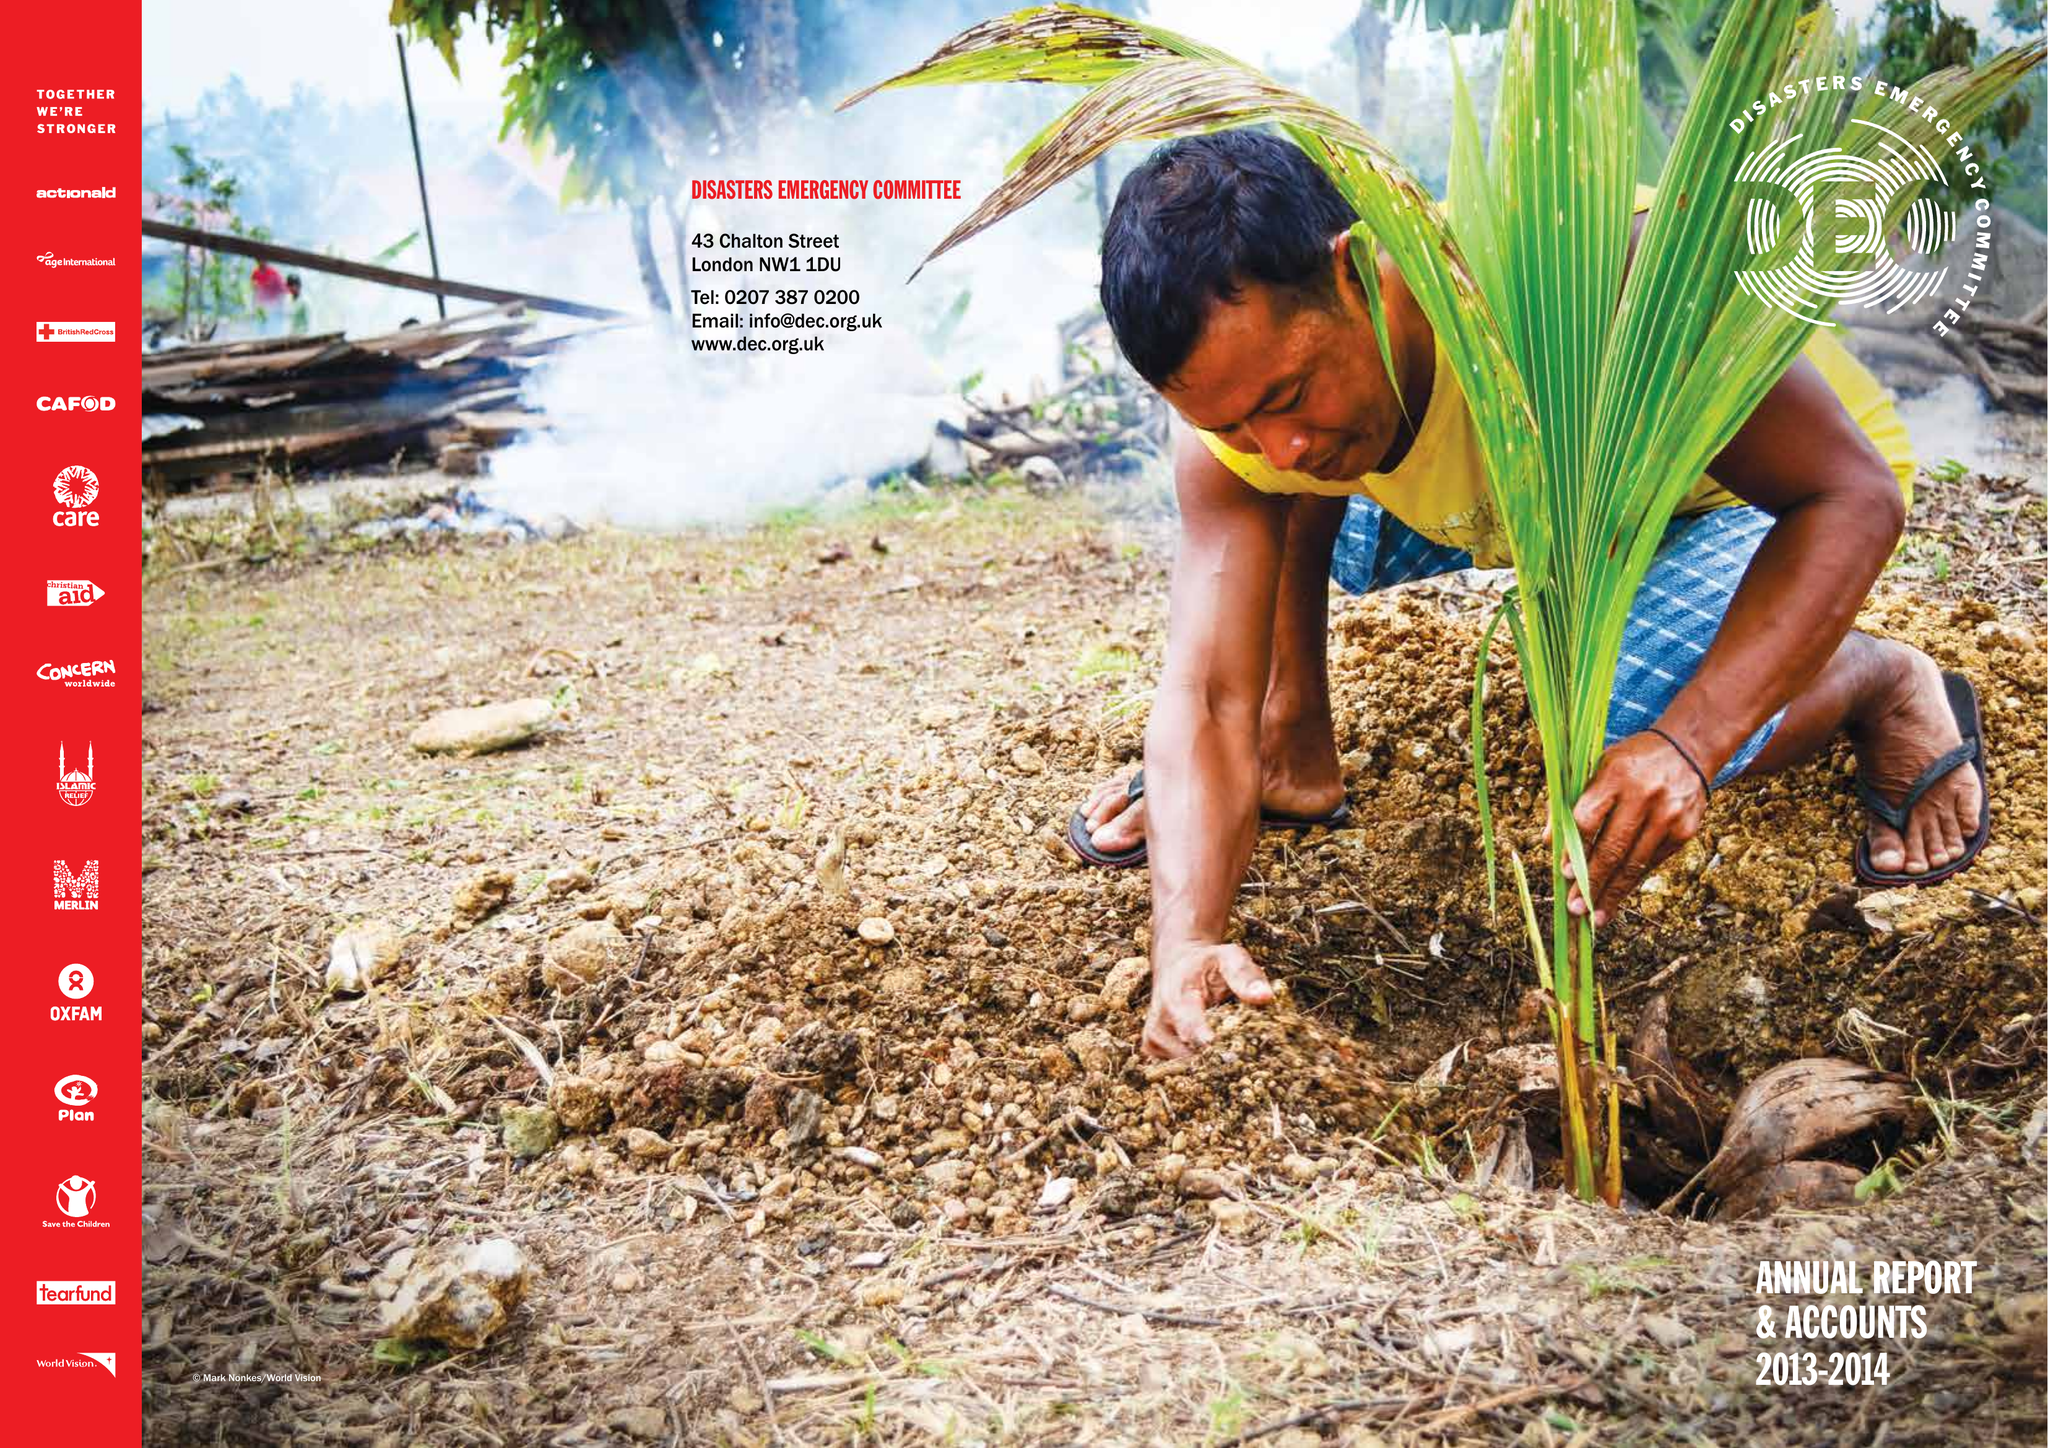What is the value for the address__post_town?
Answer the question using a single word or phrase. LONDON 